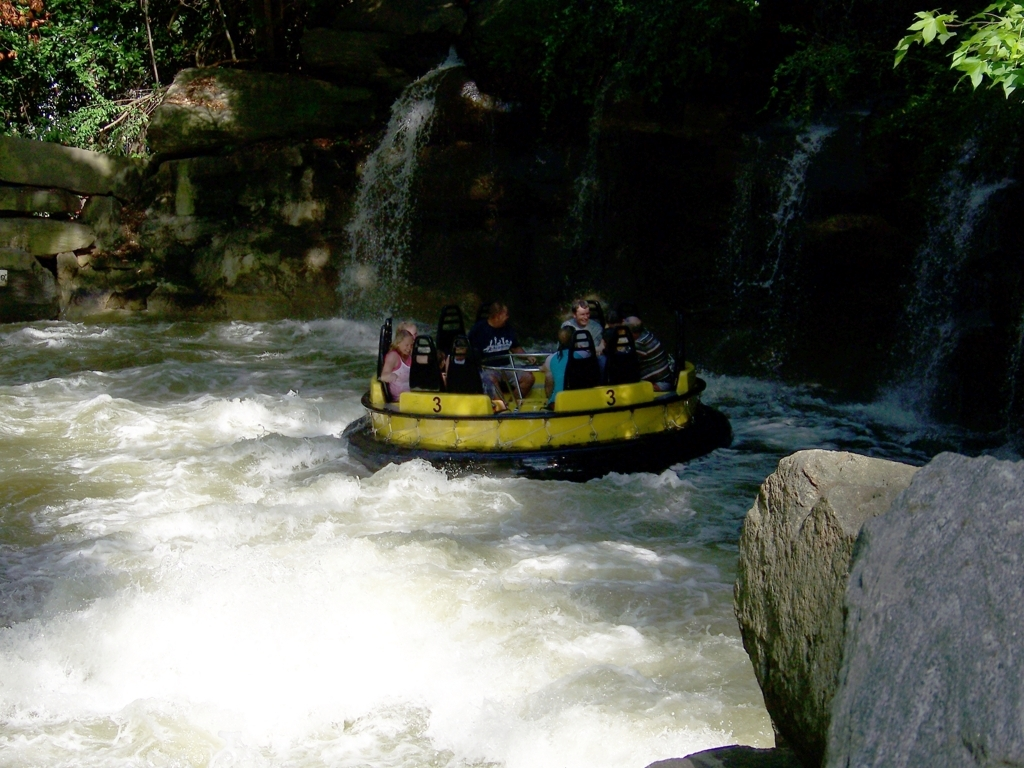Is the brightness dark?
A. Yes
B. No
Answer with the option's letter from the given choices directly.
 A. 